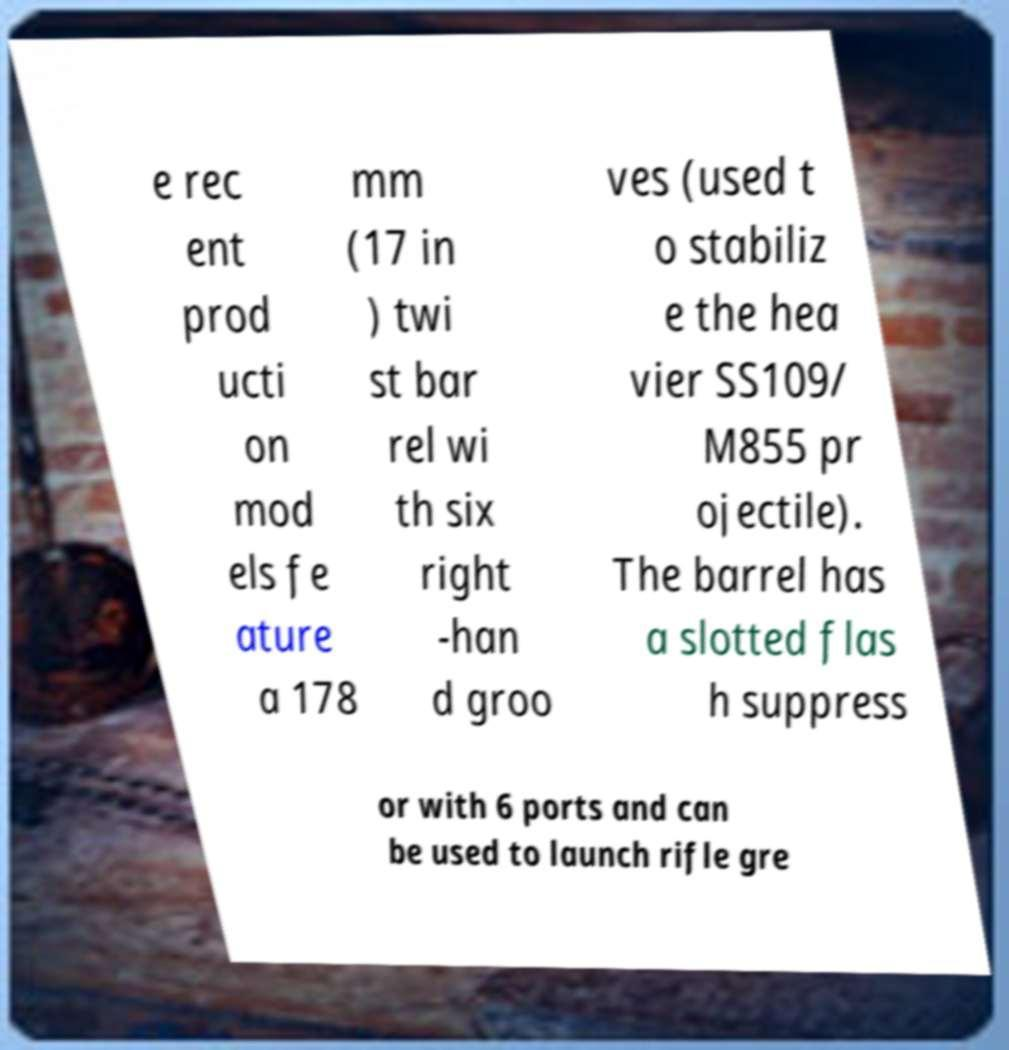There's text embedded in this image that I need extracted. Can you transcribe it verbatim? e rec ent prod ucti on mod els fe ature a 178 mm (17 in ) twi st bar rel wi th six right -han d groo ves (used t o stabiliz e the hea vier SS109/ M855 pr ojectile). The barrel has a slotted flas h suppress or with 6 ports and can be used to launch rifle gre 